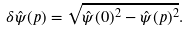<formula> <loc_0><loc_0><loc_500><loc_500>\delta \hat { \psi } ( p ) = \sqrt { \hat { \psi } ( 0 ) ^ { 2 } - \hat { \psi } ( p ) ^ { 2 } } .</formula> 